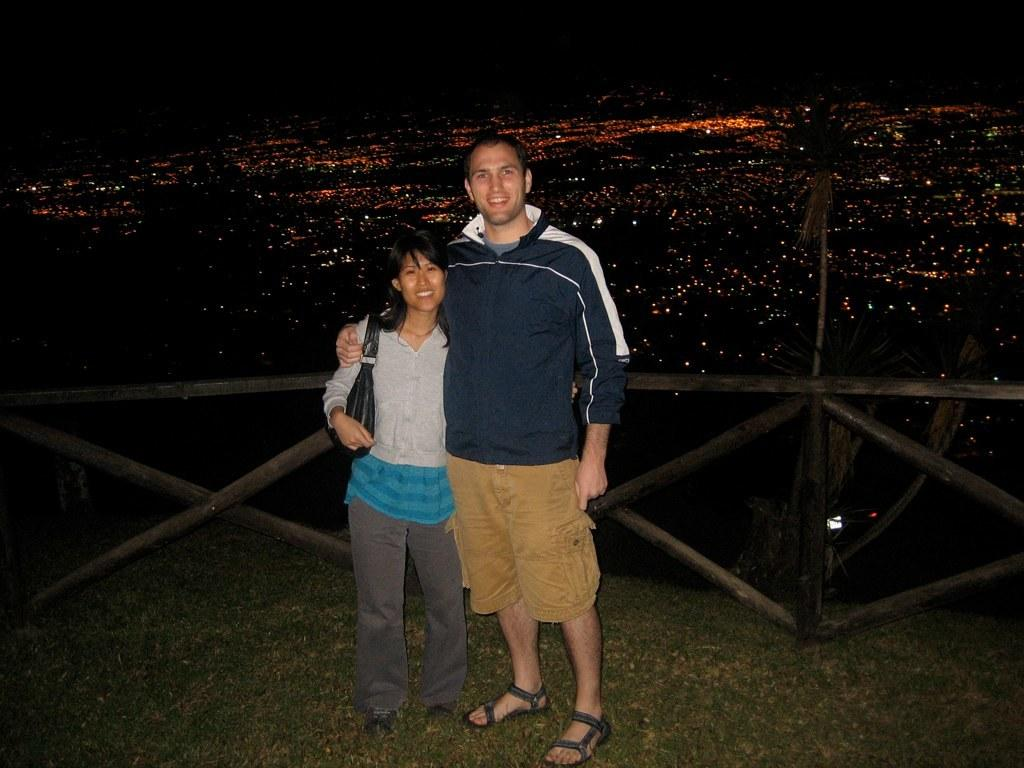How many people are in the image? There are two persons in the image. What are the persons doing in the image? The persons are standing and smiling. What can be seen in the background of the image? There is a wooden fence and grass in the image. Are there any artificial light sources visible in the image? Yes, there are lights in the image. What type of root can be seen growing through the grass in the image? There is no root visible in the image; it only shows grass and a wooden fence. What place is depicted in the image? The image does not depict a specific place; it only shows two people standing and smiling, along with a wooden fence and grass. 